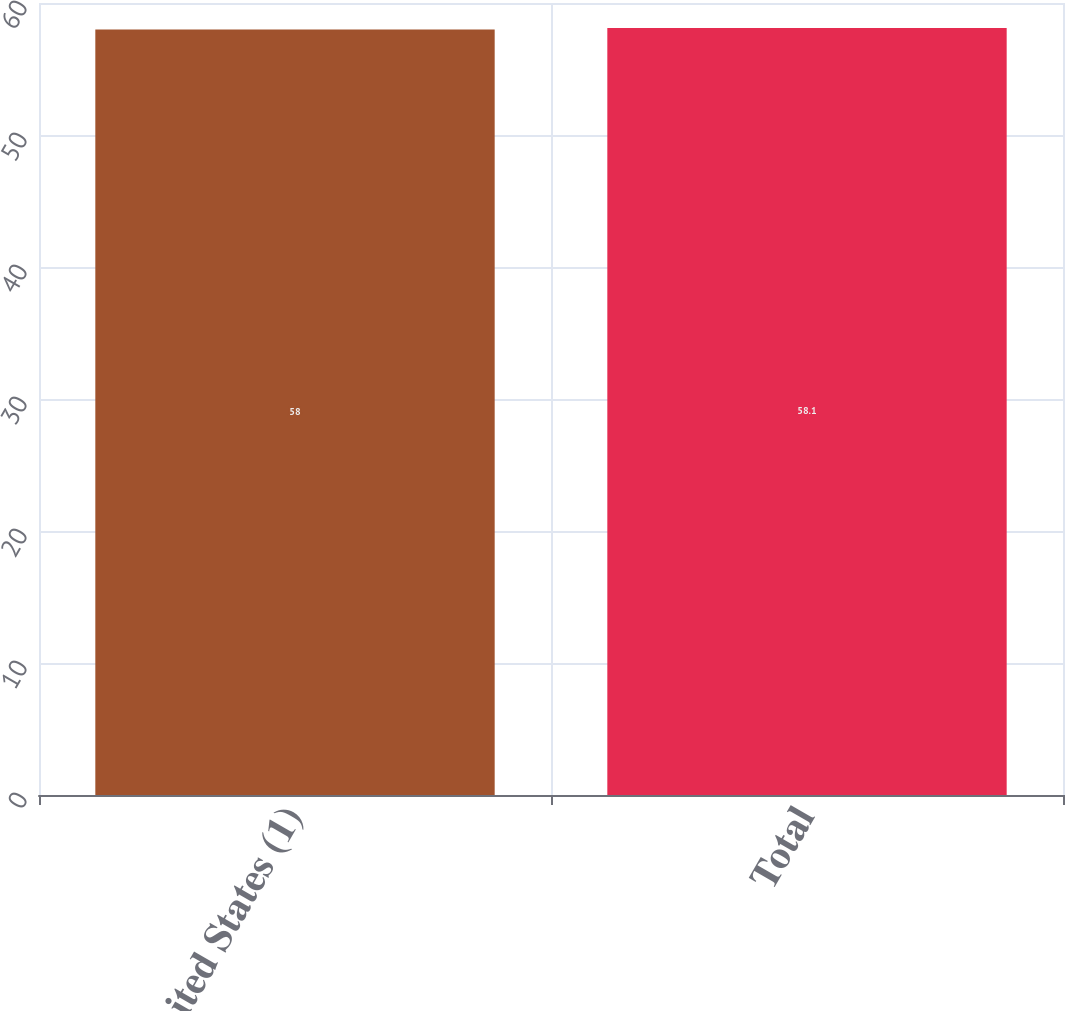Convert chart. <chart><loc_0><loc_0><loc_500><loc_500><bar_chart><fcel>United States (1)<fcel>Total<nl><fcel>58<fcel>58.1<nl></chart> 